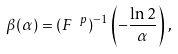<formula> <loc_0><loc_0><loc_500><loc_500>\beta ( \alpha ) = ( F ^ { \ p } ) ^ { - 1 } \left ( - \frac { \ln 2 } { \alpha } \right ) \, ,</formula> 